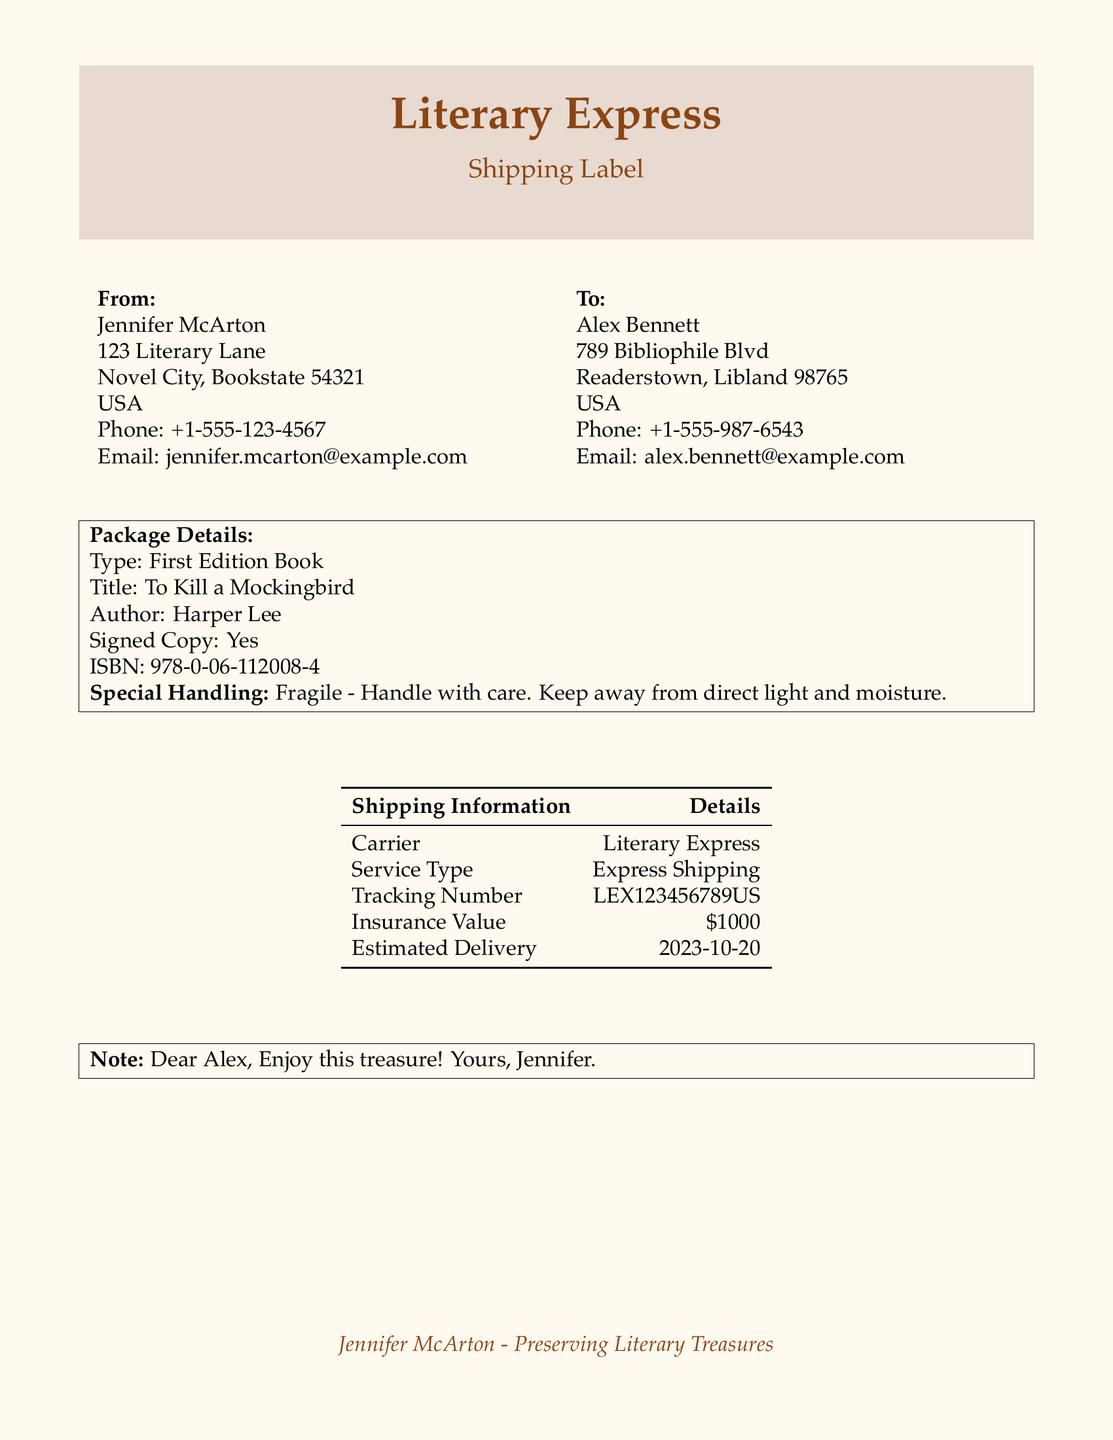What is the sender's name? The sender's name is listed at the top of the document under "From".
Answer: Jennifer McArton What is the recipient's city? The recipient's city is indicated in the "To" section of the document.
Answer: Readerstown What is the title of the book being shipped? The title is specified under "Package Details".
Answer: To Kill a Mockingbird What is the ISBN of the book? The ISBN can be found in the "Package Details" section.
Answer: 978-0-06-112008-4 What is the insurance value of the package? The insurance value is mentioned in the "Shipping Information" table.
Answer: $1000 How is the package labeled for handling? The handling instruction is provided in the "Package Details" section.
Answer: Fragile - Handle with care On what date is the estimated delivery? The estimated delivery date is listed in the "Shipping Information" section.
Answer: 2023-10-20 What type of shipping service is used? The type of service is noted in the "Shipping Information" table.
Answer: Express Shipping What message is included in the note? The note is given in the boxed message at the bottom of the document.
Answer: Enjoy this treasure! Yours, Jennifer 